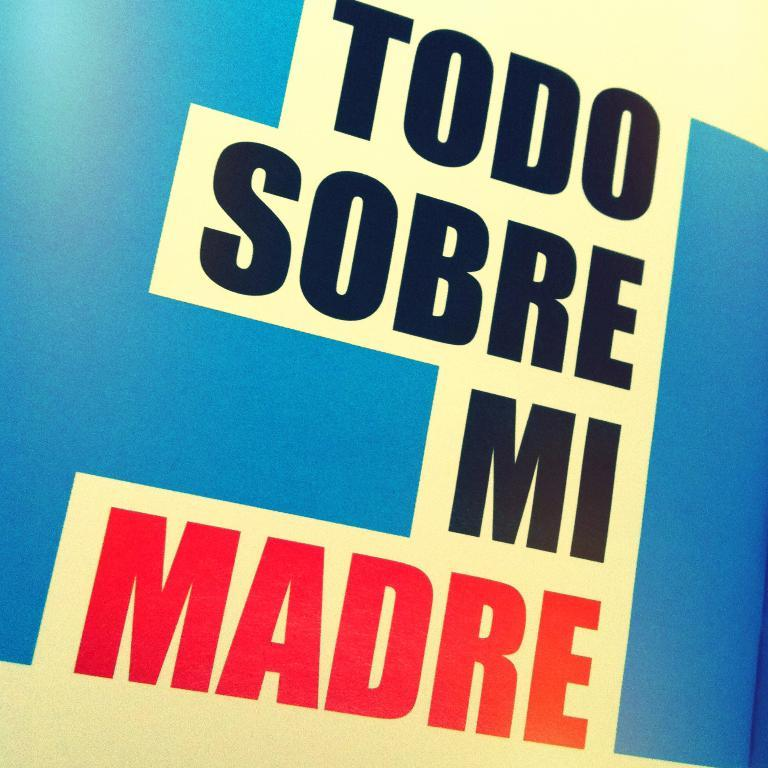<image>
Summarize the visual content of the image. A blue and white sign that says TODO SOBRE MI MADRE. 